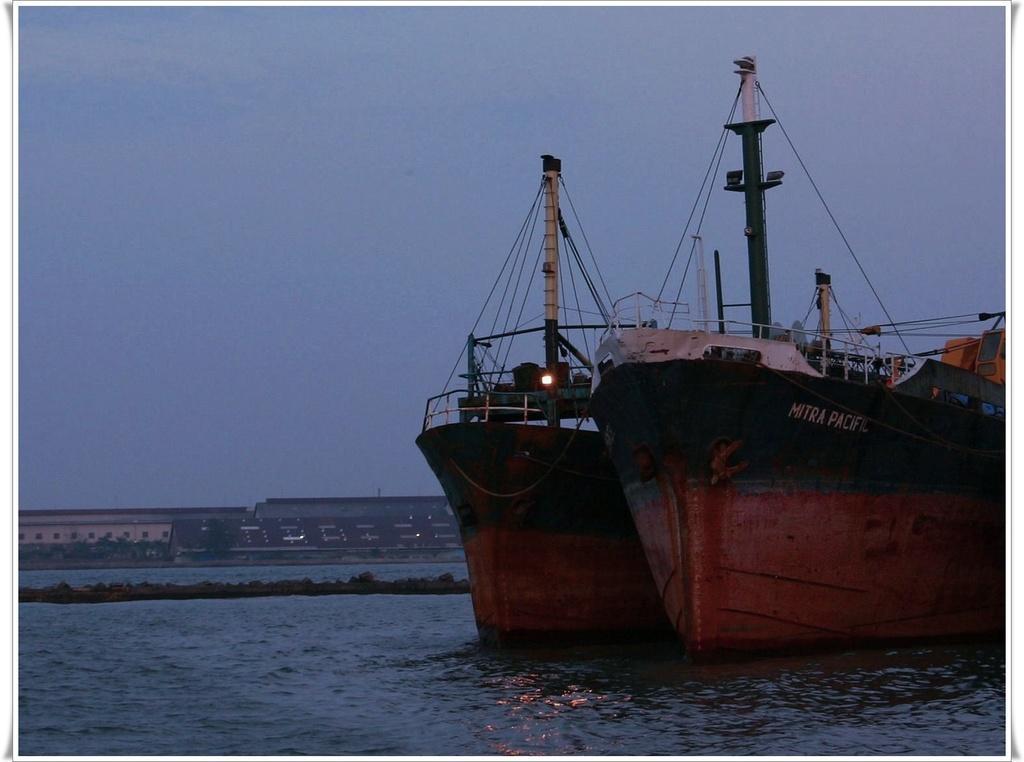Could you give a brief overview of what you see in this image? In this image there are two ships on the water. In the background there are buildings, trees and sky. 